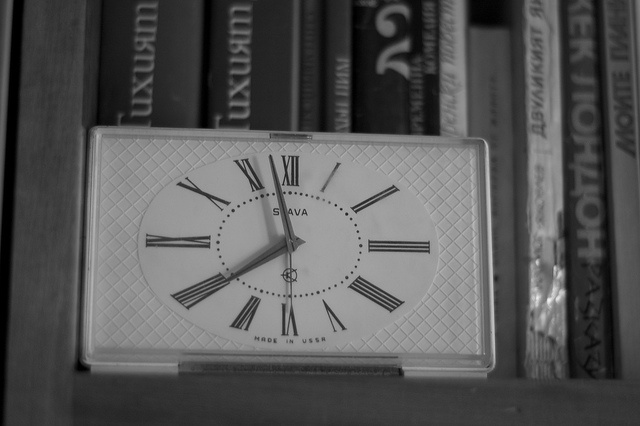Describe the objects in this image and their specific colors. I can see clock in black, darkgray, gray, and lightgray tones, book in black, gray, and lightgray tones, book in black and gray tones, book in black and gray tones, and book in black and gray tones in this image. 